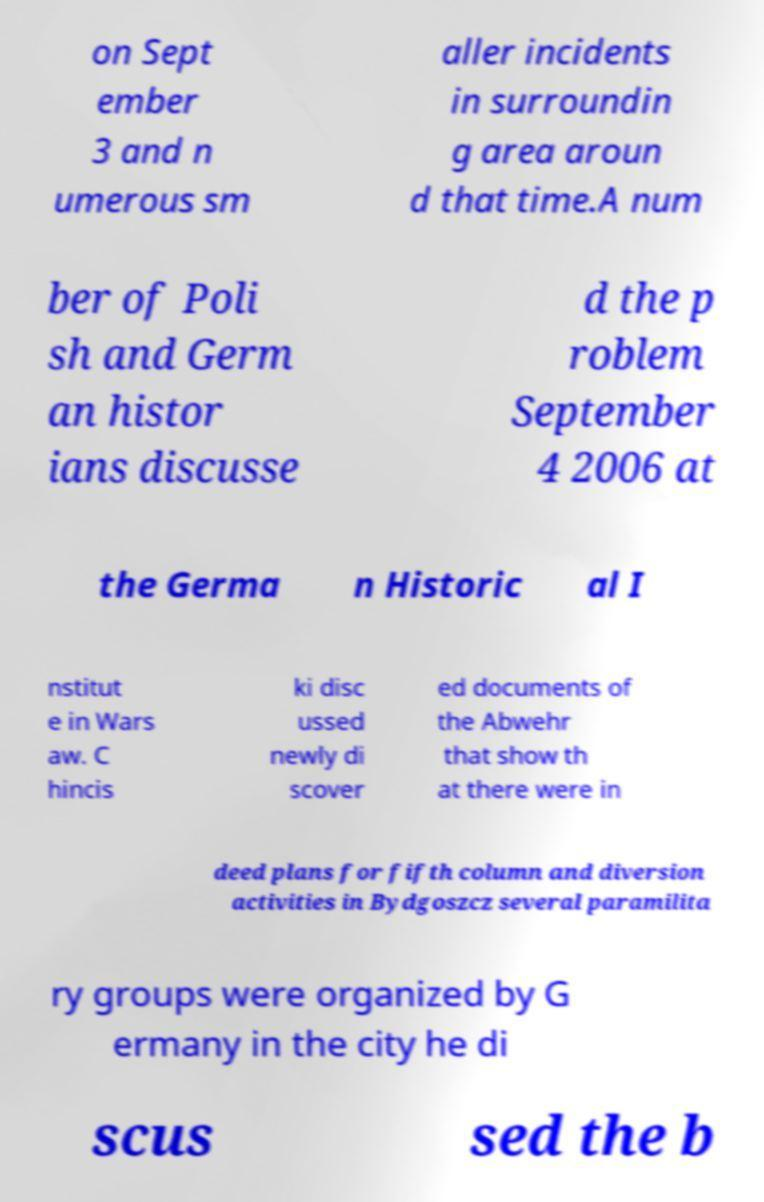Can you accurately transcribe the text from the provided image for me? on Sept ember 3 and n umerous sm aller incidents in surroundin g area aroun d that time.A num ber of Poli sh and Germ an histor ians discusse d the p roblem September 4 2006 at the Germa n Historic al I nstitut e in Wars aw. C hincis ki disc ussed newly di scover ed documents of the Abwehr that show th at there were in deed plans for fifth column and diversion activities in Bydgoszcz several paramilita ry groups were organized by G ermany in the city he di scus sed the b 